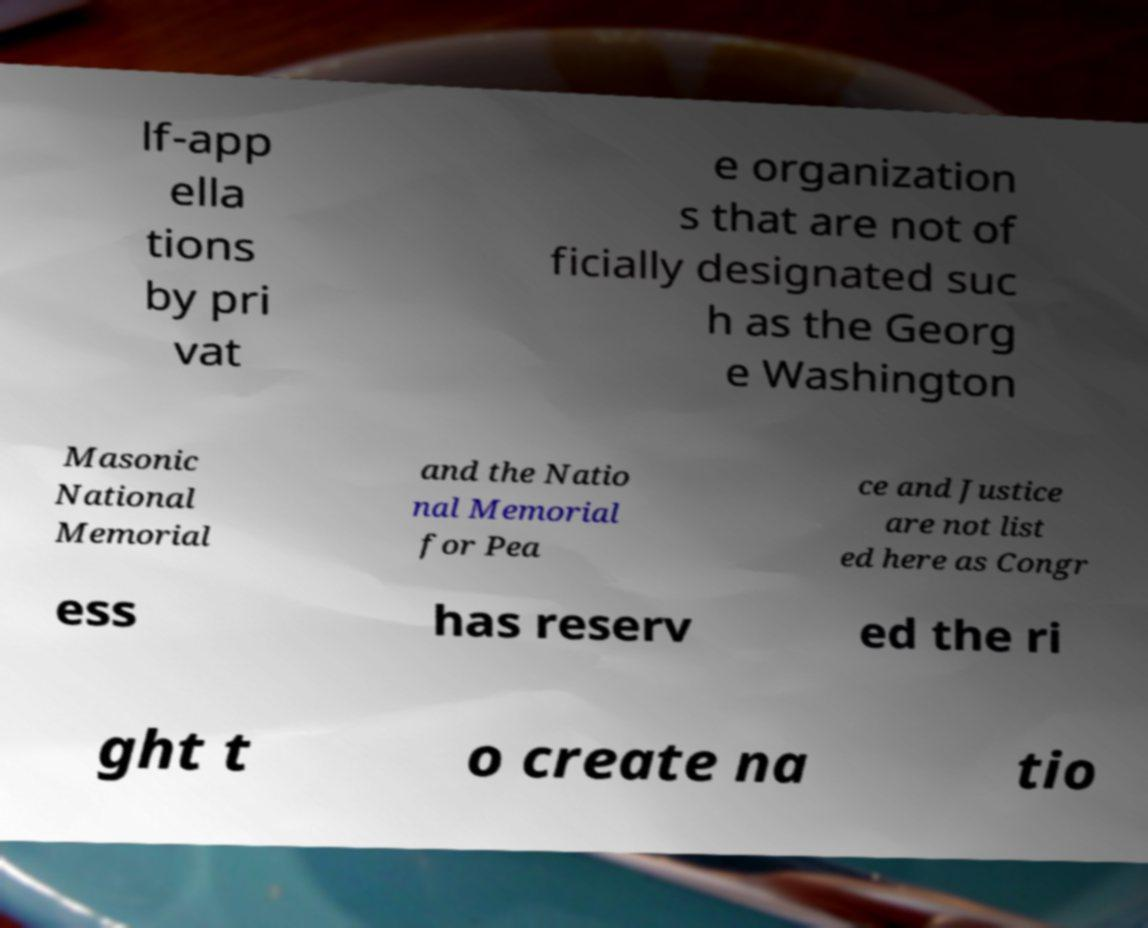I need the written content from this picture converted into text. Can you do that? lf-app ella tions by pri vat e organization s that are not of ficially designated suc h as the Georg e Washington Masonic National Memorial and the Natio nal Memorial for Pea ce and Justice are not list ed here as Congr ess has reserv ed the ri ght t o create na tio 